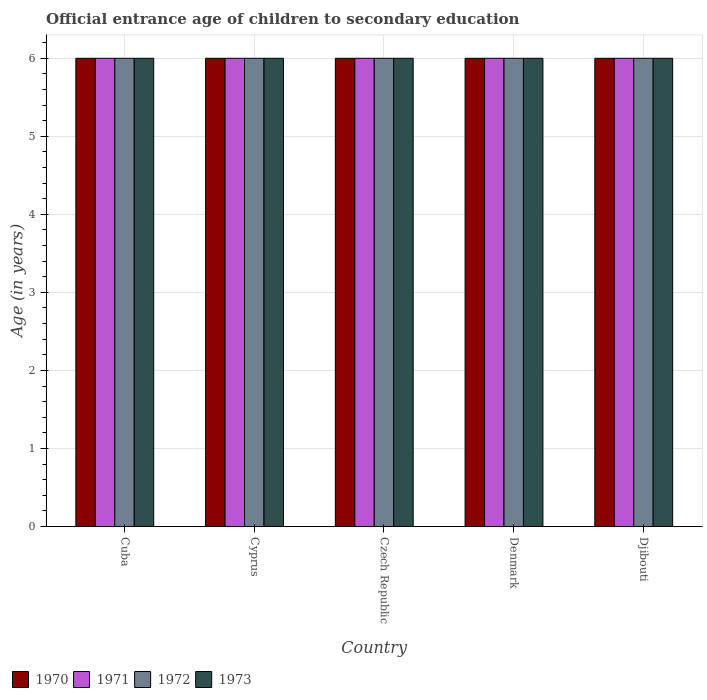How many different coloured bars are there?
Offer a very short reply. 4. How many bars are there on the 3rd tick from the left?
Your response must be concise. 4. How many bars are there on the 4th tick from the right?
Offer a very short reply. 4. What is the label of the 1st group of bars from the left?
Make the answer very short. Cuba. Across all countries, what is the maximum secondary school starting age of children in 1973?
Make the answer very short. 6. Across all countries, what is the minimum secondary school starting age of children in 1971?
Offer a very short reply. 6. In which country was the secondary school starting age of children in 1971 maximum?
Your response must be concise. Cuba. In which country was the secondary school starting age of children in 1972 minimum?
Keep it short and to the point. Cuba. What is the total secondary school starting age of children in 1971 in the graph?
Give a very brief answer. 30. What is the difference between the secondary school starting age of children in 1970 in Cuba and that in Czech Republic?
Keep it short and to the point. 0. What is the average secondary school starting age of children in 1970 per country?
Offer a very short reply. 6. In how many countries, is the secondary school starting age of children in 1973 greater than 5.2 years?
Give a very brief answer. 5. What is the ratio of the secondary school starting age of children in 1972 in Cuba to that in Djibouti?
Provide a succinct answer. 1. Is the secondary school starting age of children in 1972 in Czech Republic less than that in Djibouti?
Your response must be concise. No. Is the difference between the secondary school starting age of children in 1972 in Czech Republic and Denmark greater than the difference between the secondary school starting age of children in 1971 in Czech Republic and Denmark?
Provide a short and direct response. No. What is the difference between the highest and the lowest secondary school starting age of children in 1973?
Provide a short and direct response. 0. In how many countries, is the secondary school starting age of children in 1970 greater than the average secondary school starting age of children in 1970 taken over all countries?
Give a very brief answer. 0. Is the sum of the secondary school starting age of children in 1970 in Cuba and Djibouti greater than the maximum secondary school starting age of children in 1972 across all countries?
Your response must be concise. Yes. What does the 4th bar from the right in Djibouti represents?
Ensure brevity in your answer.  1970. Are all the bars in the graph horizontal?
Keep it short and to the point. No. What is the difference between two consecutive major ticks on the Y-axis?
Provide a succinct answer. 1. Where does the legend appear in the graph?
Your response must be concise. Bottom left. How many legend labels are there?
Provide a short and direct response. 4. What is the title of the graph?
Your response must be concise. Official entrance age of children to secondary education. Does "1980" appear as one of the legend labels in the graph?
Give a very brief answer. No. What is the label or title of the Y-axis?
Provide a short and direct response. Age (in years). What is the Age (in years) in 1970 in Cuba?
Give a very brief answer. 6. What is the Age (in years) in 1971 in Cuba?
Ensure brevity in your answer.  6. What is the Age (in years) in 1972 in Cuba?
Provide a short and direct response. 6. What is the Age (in years) of 1970 in Cyprus?
Ensure brevity in your answer.  6. What is the Age (in years) of 1972 in Cyprus?
Make the answer very short. 6. What is the Age (in years) in 1970 in Denmark?
Your response must be concise. 6. What is the Age (in years) in 1972 in Denmark?
Your answer should be compact. 6. What is the Age (in years) in 1973 in Denmark?
Your response must be concise. 6. What is the Age (in years) of 1970 in Djibouti?
Your answer should be very brief. 6. What is the Age (in years) in 1971 in Djibouti?
Give a very brief answer. 6. What is the Age (in years) of 1972 in Djibouti?
Make the answer very short. 6. What is the Age (in years) in 1973 in Djibouti?
Your answer should be compact. 6. Across all countries, what is the maximum Age (in years) in 1970?
Your answer should be very brief. 6. Across all countries, what is the maximum Age (in years) in 1971?
Your answer should be very brief. 6. Across all countries, what is the maximum Age (in years) in 1973?
Offer a very short reply. 6. Across all countries, what is the minimum Age (in years) in 1970?
Give a very brief answer. 6. Across all countries, what is the minimum Age (in years) in 1971?
Your answer should be very brief. 6. Across all countries, what is the minimum Age (in years) in 1972?
Your answer should be compact. 6. Across all countries, what is the minimum Age (in years) of 1973?
Your answer should be very brief. 6. What is the total Age (in years) of 1970 in the graph?
Your response must be concise. 30. What is the total Age (in years) in 1971 in the graph?
Your response must be concise. 30. What is the difference between the Age (in years) of 1971 in Cuba and that in Cyprus?
Your response must be concise. 0. What is the difference between the Age (in years) of 1972 in Cuba and that in Cyprus?
Your answer should be very brief. 0. What is the difference between the Age (in years) of 1970 in Cuba and that in Czech Republic?
Your answer should be very brief. 0. What is the difference between the Age (in years) in 1971 in Cuba and that in Czech Republic?
Provide a short and direct response. 0. What is the difference between the Age (in years) of 1973 in Cuba and that in Czech Republic?
Ensure brevity in your answer.  0. What is the difference between the Age (in years) in 1970 in Cuba and that in Denmark?
Provide a succinct answer. 0. What is the difference between the Age (in years) of 1971 in Cuba and that in Denmark?
Your answer should be compact. 0. What is the difference between the Age (in years) in 1970 in Cuba and that in Djibouti?
Provide a succinct answer. 0. What is the difference between the Age (in years) of 1972 in Cuba and that in Djibouti?
Provide a succinct answer. 0. What is the difference between the Age (in years) in 1973 in Cuba and that in Djibouti?
Your answer should be very brief. 0. What is the difference between the Age (in years) in 1971 in Cyprus and that in Czech Republic?
Provide a succinct answer. 0. What is the difference between the Age (in years) of 1973 in Cyprus and that in Czech Republic?
Offer a terse response. 0. What is the difference between the Age (in years) of 1970 in Cyprus and that in Denmark?
Make the answer very short. 0. What is the difference between the Age (in years) of 1971 in Cyprus and that in Denmark?
Keep it short and to the point. 0. What is the difference between the Age (in years) of 1972 in Cyprus and that in Denmark?
Provide a succinct answer. 0. What is the difference between the Age (in years) in 1971 in Cyprus and that in Djibouti?
Provide a short and direct response. 0. What is the difference between the Age (in years) in 1972 in Cyprus and that in Djibouti?
Provide a succinct answer. 0. What is the difference between the Age (in years) of 1970 in Czech Republic and that in Denmark?
Your answer should be compact. 0. What is the difference between the Age (in years) of 1971 in Czech Republic and that in Denmark?
Your answer should be very brief. 0. What is the difference between the Age (in years) of 1970 in Czech Republic and that in Djibouti?
Your response must be concise. 0. What is the difference between the Age (in years) of 1971 in Czech Republic and that in Djibouti?
Your answer should be compact. 0. What is the difference between the Age (in years) in 1973 in Czech Republic and that in Djibouti?
Offer a terse response. 0. What is the difference between the Age (in years) of 1970 in Denmark and that in Djibouti?
Keep it short and to the point. 0. What is the difference between the Age (in years) of 1971 in Denmark and that in Djibouti?
Ensure brevity in your answer.  0. What is the difference between the Age (in years) of 1970 in Cuba and the Age (in years) of 1971 in Cyprus?
Offer a terse response. 0. What is the difference between the Age (in years) in 1972 in Cuba and the Age (in years) in 1973 in Cyprus?
Your answer should be very brief. 0. What is the difference between the Age (in years) of 1970 in Cuba and the Age (in years) of 1971 in Czech Republic?
Your answer should be compact. 0. What is the difference between the Age (in years) in 1970 in Cuba and the Age (in years) in 1973 in Czech Republic?
Make the answer very short. 0. What is the difference between the Age (in years) in 1970 in Cuba and the Age (in years) in 1971 in Denmark?
Your answer should be compact. 0. What is the difference between the Age (in years) of 1971 in Cuba and the Age (in years) of 1972 in Denmark?
Your answer should be compact. 0. What is the difference between the Age (in years) of 1971 in Cuba and the Age (in years) of 1973 in Denmark?
Your answer should be compact. 0. What is the difference between the Age (in years) in 1970 in Cuba and the Age (in years) in 1971 in Djibouti?
Offer a terse response. 0. What is the difference between the Age (in years) in 1970 in Cuba and the Age (in years) in 1973 in Djibouti?
Provide a succinct answer. 0. What is the difference between the Age (in years) in 1972 in Cuba and the Age (in years) in 1973 in Djibouti?
Ensure brevity in your answer.  0. What is the difference between the Age (in years) of 1970 in Cyprus and the Age (in years) of 1971 in Czech Republic?
Offer a very short reply. 0. What is the difference between the Age (in years) in 1970 in Cyprus and the Age (in years) in 1972 in Czech Republic?
Ensure brevity in your answer.  0. What is the difference between the Age (in years) in 1970 in Cyprus and the Age (in years) in 1973 in Czech Republic?
Make the answer very short. 0. What is the difference between the Age (in years) of 1971 in Cyprus and the Age (in years) of 1972 in Czech Republic?
Provide a succinct answer. 0. What is the difference between the Age (in years) of 1971 in Cyprus and the Age (in years) of 1973 in Czech Republic?
Keep it short and to the point. 0. What is the difference between the Age (in years) of 1972 in Cyprus and the Age (in years) of 1973 in Czech Republic?
Ensure brevity in your answer.  0. What is the difference between the Age (in years) of 1971 in Cyprus and the Age (in years) of 1973 in Denmark?
Give a very brief answer. 0. What is the difference between the Age (in years) of 1972 in Cyprus and the Age (in years) of 1973 in Denmark?
Your answer should be very brief. 0. What is the difference between the Age (in years) in 1970 in Cyprus and the Age (in years) in 1971 in Djibouti?
Offer a very short reply. 0. What is the difference between the Age (in years) of 1970 in Cyprus and the Age (in years) of 1972 in Djibouti?
Your response must be concise. 0. What is the difference between the Age (in years) in 1971 in Cyprus and the Age (in years) in 1972 in Djibouti?
Make the answer very short. 0. What is the difference between the Age (in years) in 1972 in Cyprus and the Age (in years) in 1973 in Djibouti?
Your answer should be very brief. 0. What is the difference between the Age (in years) in 1970 in Czech Republic and the Age (in years) in 1971 in Denmark?
Give a very brief answer. 0. What is the difference between the Age (in years) in 1970 in Czech Republic and the Age (in years) in 1972 in Denmark?
Your response must be concise. 0. What is the difference between the Age (in years) in 1971 in Czech Republic and the Age (in years) in 1973 in Denmark?
Offer a very short reply. 0. What is the difference between the Age (in years) in 1972 in Czech Republic and the Age (in years) in 1973 in Denmark?
Your answer should be compact. 0. What is the difference between the Age (in years) in 1970 in Czech Republic and the Age (in years) in 1972 in Djibouti?
Provide a short and direct response. 0. What is the difference between the Age (in years) of 1972 in Czech Republic and the Age (in years) of 1973 in Djibouti?
Provide a short and direct response. 0. What is the difference between the Age (in years) in 1970 in Denmark and the Age (in years) in 1973 in Djibouti?
Ensure brevity in your answer.  0. What is the difference between the Age (in years) in 1971 in Denmark and the Age (in years) in 1972 in Djibouti?
Ensure brevity in your answer.  0. What is the difference between the Age (in years) in 1972 in Denmark and the Age (in years) in 1973 in Djibouti?
Make the answer very short. 0. What is the average Age (in years) in 1970 per country?
Ensure brevity in your answer.  6. What is the average Age (in years) in 1971 per country?
Make the answer very short. 6. What is the average Age (in years) of 1972 per country?
Make the answer very short. 6. What is the difference between the Age (in years) in 1970 and Age (in years) in 1971 in Cuba?
Offer a terse response. 0. What is the difference between the Age (in years) in 1971 and Age (in years) in 1972 in Cuba?
Provide a succinct answer. 0. What is the difference between the Age (in years) in 1971 and Age (in years) in 1973 in Cuba?
Keep it short and to the point. 0. What is the difference between the Age (in years) of 1970 and Age (in years) of 1971 in Cyprus?
Keep it short and to the point. 0. What is the difference between the Age (in years) of 1970 and Age (in years) of 1972 in Cyprus?
Make the answer very short. 0. What is the difference between the Age (in years) in 1970 and Age (in years) in 1973 in Cyprus?
Provide a short and direct response. 0. What is the difference between the Age (in years) of 1970 and Age (in years) of 1973 in Czech Republic?
Offer a terse response. 0. What is the difference between the Age (in years) of 1970 and Age (in years) of 1973 in Denmark?
Your response must be concise. 0. What is the difference between the Age (in years) in 1971 and Age (in years) in 1973 in Denmark?
Provide a succinct answer. 0. What is the difference between the Age (in years) of 1970 and Age (in years) of 1973 in Djibouti?
Provide a short and direct response. 0. What is the difference between the Age (in years) in 1972 and Age (in years) in 1973 in Djibouti?
Keep it short and to the point. 0. What is the ratio of the Age (in years) of 1970 in Cuba to that in Czech Republic?
Keep it short and to the point. 1. What is the ratio of the Age (in years) in 1972 in Cuba to that in Czech Republic?
Offer a very short reply. 1. What is the ratio of the Age (in years) in 1970 in Cuba to that in Denmark?
Your answer should be compact. 1. What is the ratio of the Age (in years) in 1971 in Cuba to that in Denmark?
Offer a very short reply. 1. What is the ratio of the Age (in years) of 1972 in Cuba to that in Denmark?
Provide a short and direct response. 1. What is the ratio of the Age (in years) of 1973 in Cuba to that in Denmark?
Provide a short and direct response. 1. What is the ratio of the Age (in years) in 1971 in Cuba to that in Djibouti?
Your answer should be compact. 1. What is the ratio of the Age (in years) in 1972 in Cuba to that in Djibouti?
Provide a succinct answer. 1. What is the ratio of the Age (in years) in 1973 in Cuba to that in Djibouti?
Your response must be concise. 1. What is the ratio of the Age (in years) in 1971 in Cyprus to that in Czech Republic?
Make the answer very short. 1. What is the ratio of the Age (in years) of 1972 in Cyprus to that in Czech Republic?
Give a very brief answer. 1. What is the ratio of the Age (in years) in 1972 in Cyprus to that in Denmark?
Your answer should be compact. 1. What is the ratio of the Age (in years) in 1971 in Cyprus to that in Djibouti?
Offer a terse response. 1. What is the ratio of the Age (in years) of 1973 in Cyprus to that in Djibouti?
Ensure brevity in your answer.  1. What is the ratio of the Age (in years) in 1970 in Czech Republic to that in Denmark?
Give a very brief answer. 1. What is the ratio of the Age (in years) of 1971 in Czech Republic to that in Denmark?
Provide a short and direct response. 1. What is the ratio of the Age (in years) of 1971 in Czech Republic to that in Djibouti?
Offer a very short reply. 1. What is the ratio of the Age (in years) in 1972 in Czech Republic to that in Djibouti?
Make the answer very short. 1. What is the ratio of the Age (in years) of 1970 in Denmark to that in Djibouti?
Provide a succinct answer. 1. What is the ratio of the Age (in years) of 1971 in Denmark to that in Djibouti?
Your answer should be very brief. 1. What is the ratio of the Age (in years) of 1972 in Denmark to that in Djibouti?
Your answer should be very brief. 1. What is the difference between the highest and the second highest Age (in years) of 1970?
Your response must be concise. 0. What is the difference between the highest and the second highest Age (in years) in 1972?
Your answer should be compact. 0. What is the difference between the highest and the second highest Age (in years) of 1973?
Your answer should be compact. 0. What is the difference between the highest and the lowest Age (in years) in 1970?
Give a very brief answer. 0. What is the difference between the highest and the lowest Age (in years) of 1971?
Give a very brief answer. 0. What is the difference between the highest and the lowest Age (in years) in 1973?
Give a very brief answer. 0. 